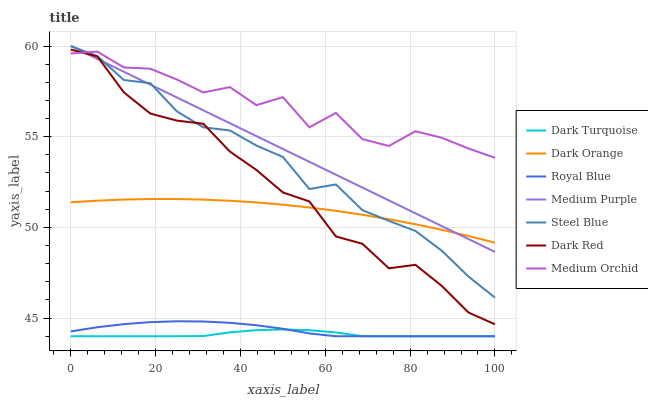Does Dark Turquoise have the minimum area under the curve?
Answer yes or no. Yes. Does Medium Orchid have the maximum area under the curve?
Answer yes or no. Yes. Does Medium Orchid have the minimum area under the curve?
Answer yes or no. No. Does Dark Turquoise have the maximum area under the curve?
Answer yes or no. No. Is Medium Purple the smoothest?
Answer yes or no. Yes. Is Medium Orchid the roughest?
Answer yes or no. Yes. Is Dark Turquoise the smoothest?
Answer yes or no. No. Is Dark Turquoise the roughest?
Answer yes or no. No. Does Dark Turquoise have the lowest value?
Answer yes or no. Yes. Does Medium Orchid have the lowest value?
Answer yes or no. No. Does Medium Purple have the highest value?
Answer yes or no. Yes. Does Medium Orchid have the highest value?
Answer yes or no. No. Is Royal Blue less than Medium Purple?
Answer yes or no. Yes. Is Dark Orange greater than Royal Blue?
Answer yes or no. Yes. Does Medium Purple intersect Dark Orange?
Answer yes or no. Yes. Is Medium Purple less than Dark Orange?
Answer yes or no. No. Is Medium Purple greater than Dark Orange?
Answer yes or no. No. Does Royal Blue intersect Medium Purple?
Answer yes or no. No. 